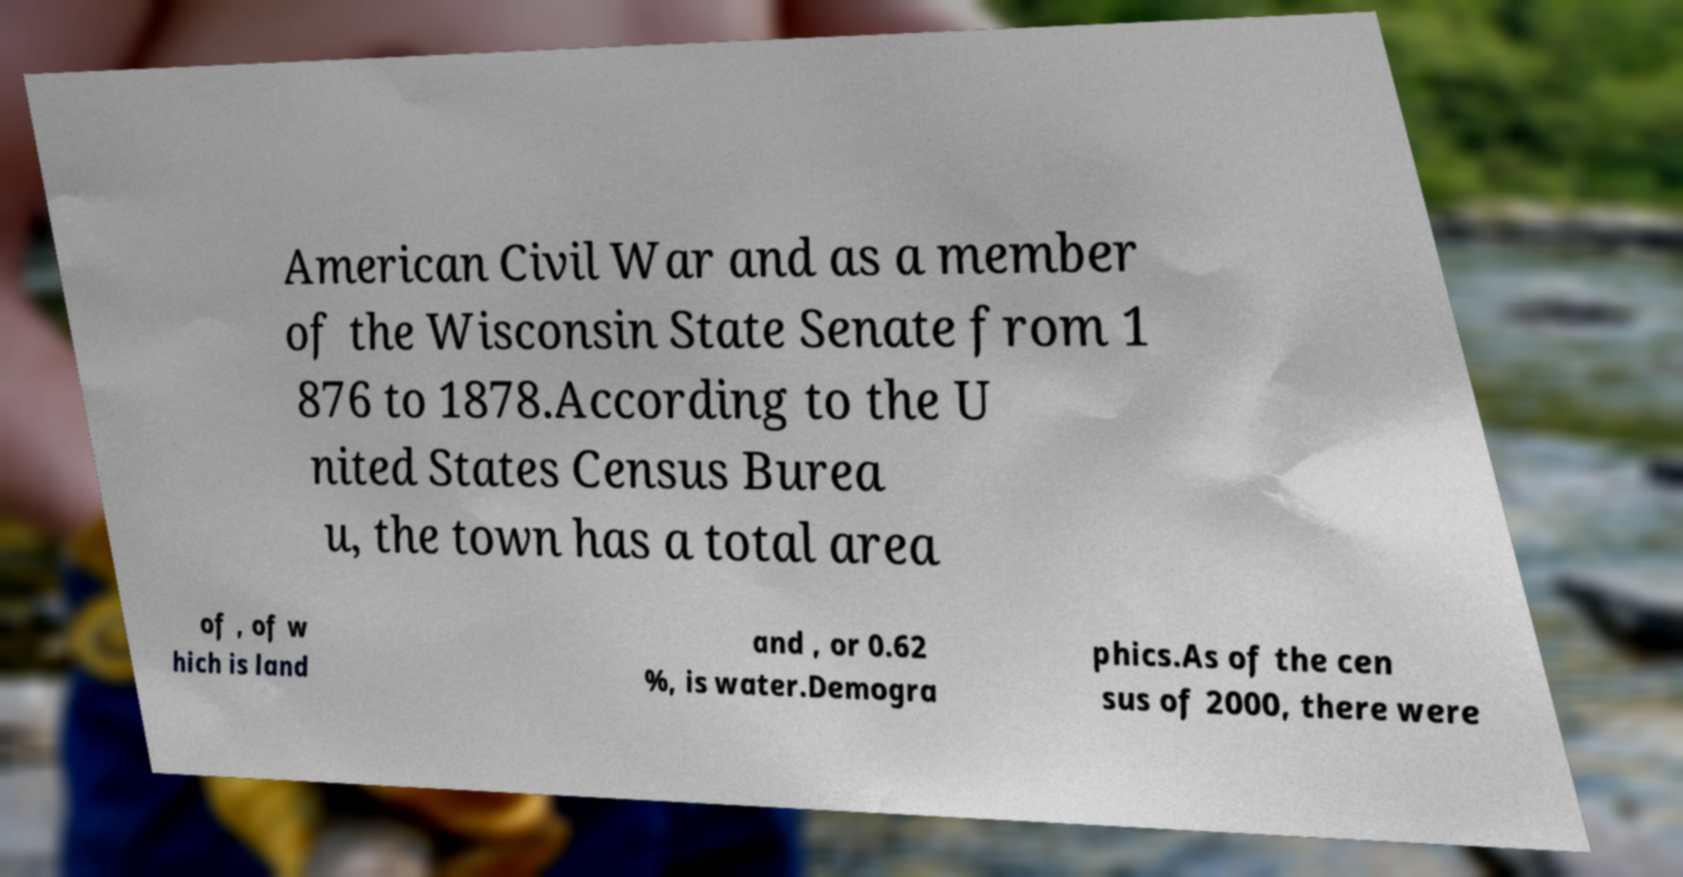Please identify and transcribe the text found in this image. American Civil War and as a member of the Wisconsin State Senate from 1 876 to 1878.According to the U nited States Census Burea u, the town has a total area of , of w hich is land and , or 0.62 %, is water.Demogra phics.As of the cen sus of 2000, there were 